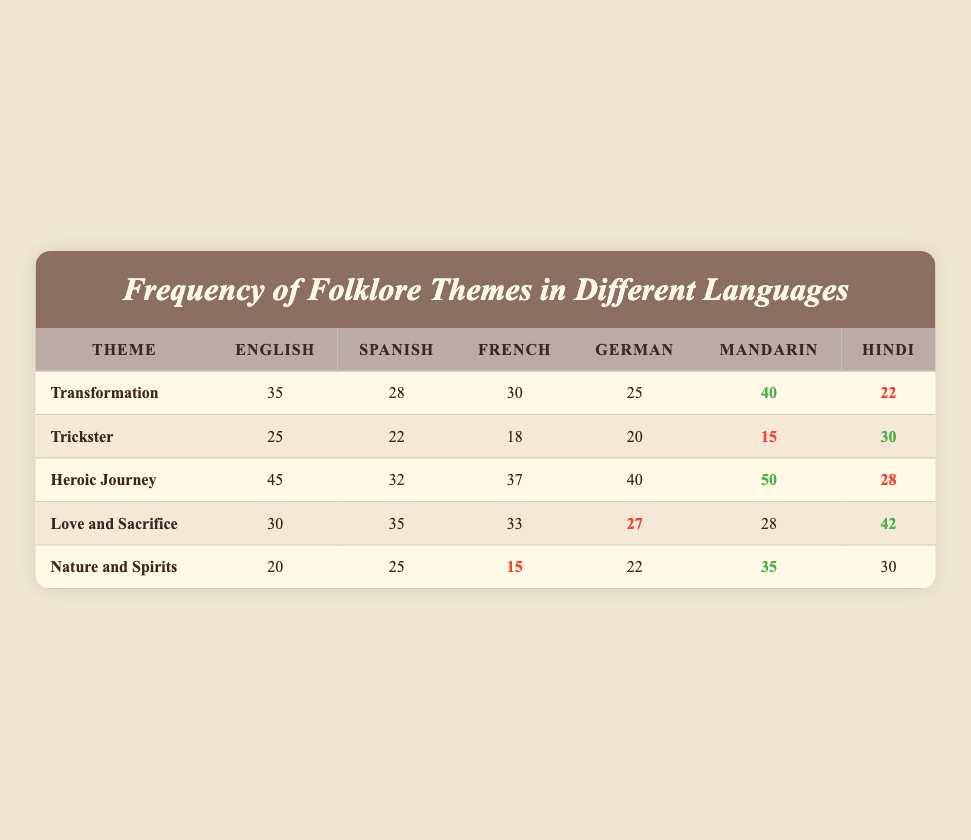What is the highest frequency of the theme "Transformation"? Looking at the "Transformation" row, the frequency values for different languages are: English: 35, Spanish: 28, French: 30, German: 25, Mandarin: 40, and Hindi: 22. The highest frequency is 40, which corresponds to Mandarin.
Answer: 40 Which language has the lowest frequency for the theme "Trickster"? In the "Trickster" row, the frequency values are: English: 25, Spanish: 22, French: 18, German: 20, Mandarin: 15, and Hindi: 30. The lowest frequency is 15, associated with Mandarin.
Answer: Mandarin What is the sum of the frequencies for the theme "Heroic Journey" in English and Hindi? For the "Heroic Journey" theme, the frequencies are: English: 45, Hindi: 28. Summing these gives 45 + 28 = 73.
Answer: 73 Is the frequency of the theme "Love and Sacrifice" in Spanish higher than in German? The values for "Love and Sacrifice" in Spanish and German are 35 and 27, respectively. Since 35 is higher than 27, the statement is true.
Answer: Yes What is the average frequency of the theme "Nature and Spirits" across all languages? The frequencies for "Nature and Spirits" are: English: 20, Spanish: 25, French: 15, German: 22, Mandarin: 35, and Hindi: 30. First, sum these values, which equals 20 + 25 + 15 + 22 + 35 + 30 = 147. Next, there are 6 languages, so divide the total by 6: 147 / 6 = 24.5.
Answer: 24.5 What is the difference in frequency between the themes "Heroic Journey" and "Trickster" in Hindi? For Hindi, the frequency of "Heroic Journey" is 28 and for "Trickster" it is 30. The difference is calculated as 30 - 28 = 2. This means "Trickster" has a frequency that is 2 higher than "Heroic Journey" in Hindi.
Answer: 2 Which theme has the highest frequency in Hindi and what is that frequency? Examining the Hindi frequencies: Transformation: 22, Trickster: 30, Heroic Journey: 28, Love and Sacrifice: 42, and Nature and Spirits: 30. The highest frequency is 42 for the theme "Love and Sacrifice."
Answer: Love and Sacrifice, 42 Is there any theme in Mandarin that has a frequency above 40? Looking at the Mandarin frequencies: Transformation: 40, Trickster: 15, Heroic Journey: 50, Love and Sacrifice: 28, and Nature and Spirits: 35. The theme "Heroic Journey" has a frequency of 50, which is above 40. Therefore, the answer is true.
Answer: Yes 